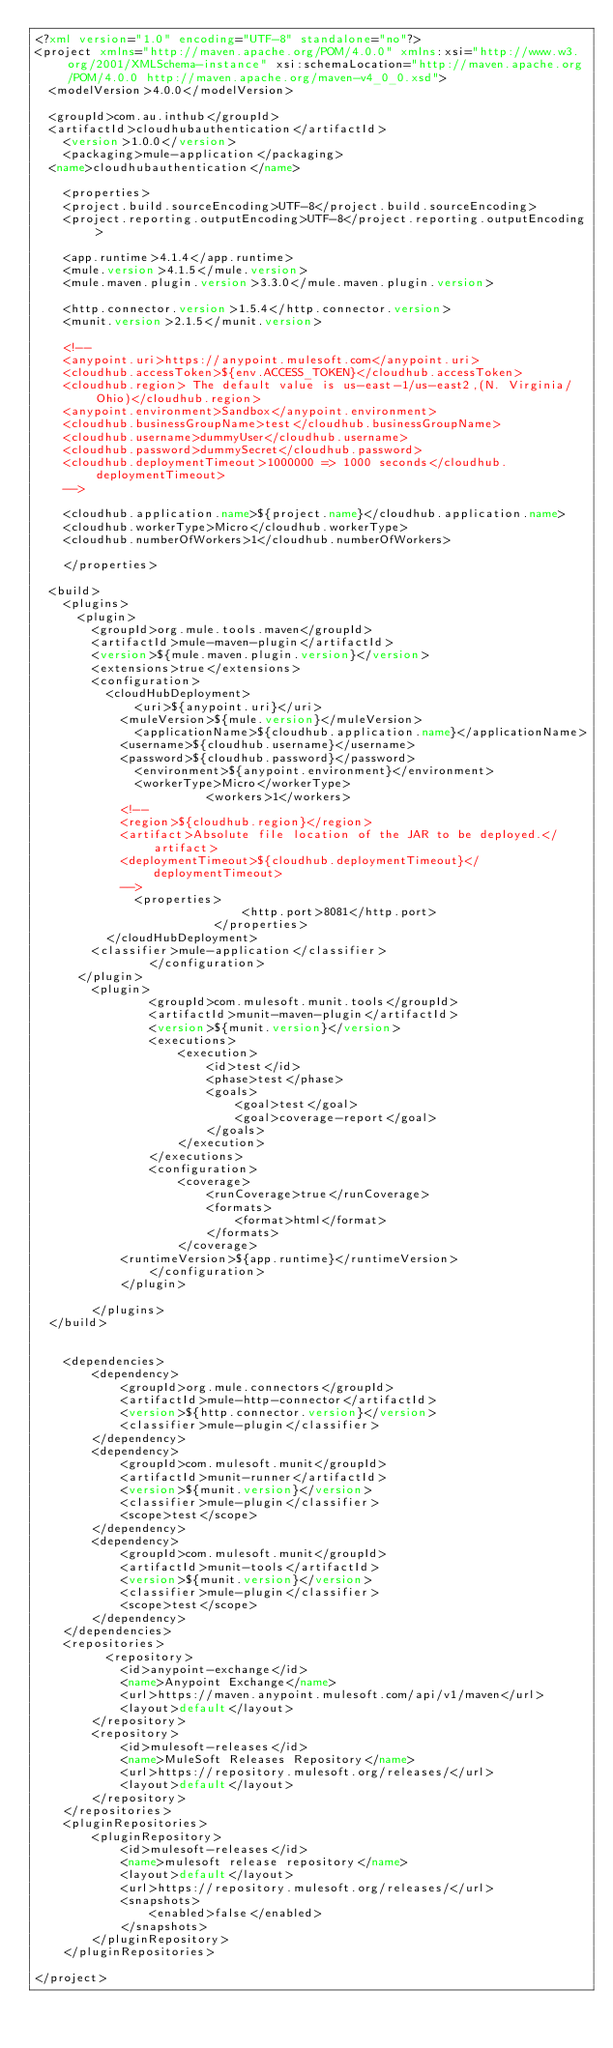Convert code to text. <code><loc_0><loc_0><loc_500><loc_500><_XML_><?xml version="1.0" encoding="UTF-8" standalone="no"?>
<project xmlns="http://maven.apache.org/POM/4.0.0" xmlns:xsi="http://www.w3.org/2001/XMLSchema-instance" xsi:schemaLocation="http://maven.apache.org/POM/4.0.0 http://maven.apache.org/maven-v4_0_0.xsd">
	<modelVersion>4.0.0</modelVersion>

	<groupId>com.au.inthub</groupId>
	<artifactId>cloudhubauthentication</artifactId>
    <version>1.0.0</version>
    <packaging>mule-application</packaging>
	<name>cloudhubauthentication</name>

    <properties>
		<project.build.sourceEncoding>UTF-8</project.build.sourceEncoding>
		<project.reporting.outputEncoding>UTF-8</project.reporting.outputEncoding>

		<app.runtime>4.1.4</app.runtime>
		<mule.version>4.1.5</mule.version>
		<mule.maven.plugin.version>3.3.0</mule.maven.plugin.version>
		
		<http.connector.version>1.5.4</http.connector.version>
		<munit.version>2.1.5</munit.version>
		
		<!-- 
		<anypoint.uri>https://anypoint.mulesoft.com</anypoint.uri>
		<cloudhub.accessToken>${env.ACCESS_TOKEN}</cloudhub.accessToken>
		<cloudhub.region> The default value is us-east-1/us-east2,(N. Virginia/Ohio)</cloudhub.region>
		<anypoint.environment>Sandbox</anypoint.environment>
		<cloudhub.businessGroupName>test</cloudhub.businessGroupName>
		<cloudhub.username>dummyUser</cloudhub.username>
		<cloudhub.password>dummySecret</cloudhub.password>
		<cloudhub.deploymentTimeout>1000000 => 1000 seconds</cloudhub.deploymentTimeout> 
		-->

		<cloudhub.application.name>${project.name}</cloudhub.application.name>
		<cloudhub.workerType>Micro</cloudhub.workerType>
		<cloudhub.numberOfWorkers>1</cloudhub.numberOfWorkers>
		
    </properties>

	<build>
		<plugins>
			<plugin>
				<groupId>org.mule.tools.maven</groupId>
				<artifactId>mule-maven-plugin</artifactId>
				<version>${mule.maven.plugin.version}</version>
				<extensions>true</extensions>
				<configuration>
					<cloudHubDeployment>
					    <uri>${anypoint.uri}</uri>
						<muleVersion>${mule.version}</muleVersion>
					    <applicationName>${cloudhub.application.name}</applicationName>
						<username>${cloudhub.username}</username>
						<password>${cloudhub.password}</password>
					    <environment>${anypoint.environment}</environment>
					    <workerType>Micro</workerType>
                      	<workers>1</workers>
						<!--
						<region>${cloudhub.region}</region>
						<artifact>Absolute file location of the JAR to be deployed.</artifact>
						<deploymentTimeout>${cloudhub.deploymentTimeout}</deploymentTimeout>
						-->
					    <properties>
                             <http.port>8081</http.port>
                         </properties>
					</cloudHubDeployment>
				<classifier>mule-application</classifier>
                </configuration>
			</plugin>
		    <plugin>
                <groupId>com.mulesoft.munit.tools</groupId>
                <artifactId>munit-maven-plugin</artifactId>
                <version>${munit.version}</version>
                <executions>
                    <execution>
                        <id>test</id>
                        <phase>test</phase>
                        <goals>
                            <goal>test</goal>
                            <goal>coverage-report</goal>
                        </goals>
                    </execution>
                </executions>
                <configuration>
                    <coverage>
                        <runCoverage>true</runCoverage>
                        <formats>
                            <format>html</format>
                        </formats>
                    </coverage>
				    <runtimeVersion>${app.runtime}</runtimeVersion>
                </configuration>
            </plugin>
			
        </plugins>
	</build>


    <dependencies>
        <dependency>
            <groupId>org.mule.connectors</groupId>
            <artifactId>mule-http-connector</artifactId>
            <version>${http.connector.version}</version>
            <classifier>mule-plugin</classifier>
        </dependency>
        <dependency>
            <groupId>com.mulesoft.munit</groupId>
            <artifactId>munit-runner</artifactId>
            <version>${munit.version}</version>
            <classifier>mule-plugin</classifier>
            <scope>test</scope>
        </dependency>
        <dependency>
            <groupId>com.mulesoft.munit</groupId>
            <artifactId>munit-tools</artifactId>
            <version>${munit.version}</version>
            <classifier>mule-plugin</classifier>
            <scope>test</scope>
        </dependency>
    </dependencies>
    <repositories>
          <repository>
            <id>anypoint-exchange</id>
            <name>Anypoint Exchange</name>
            <url>https://maven.anypoint.mulesoft.com/api/v1/maven</url>
            <layout>default</layout>
        </repository>
        <repository>
            <id>mulesoft-releases</id>
            <name>MuleSoft Releases Repository</name>
            <url>https://repository.mulesoft.org/releases/</url>
            <layout>default</layout>
        </repository>
    </repositories>
    <pluginRepositories>
        <pluginRepository>
            <id>mulesoft-releases</id>
            <name>mulesoft release repository</name>
            <layout>default</layout>
            <url>https://repository.mulesoft.org/releases/</url>
            <snapshots>
                <enabled>false</enabled>
            </snapshots>
        </pluginRepository>
    </pluginRepositories>
	
</project>
</code> 